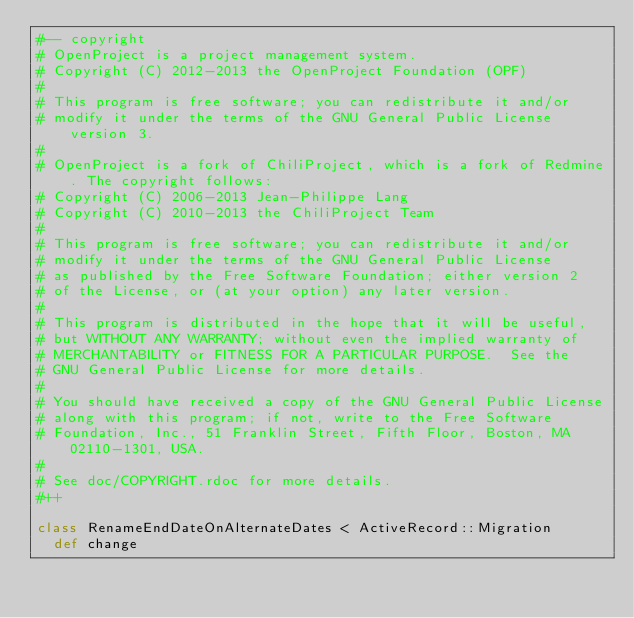<code> <loc_0><loc_0><loc_500><loc_500><_Ruby_>#-- copyright
# OpenProject is a project management system.
# Copyright (C) 2012-2013 the OpenProject Foundation (OPF)
#
# This program is free software; you can redistribute it and/or
# modify it under the terms of the GNU General Public License version 3.
#
# OpenProject is a fork of ChiliProject, which is a fork of Redmine. The copyright follows:
# Copyright (C) 2006-2013 Jean-Philippe Lang
# Copyright (C) 2010-2013 the ChiliProject Team
#
# This program is free software; you can redistribute it and/or
# modify it under the terms of the GNU General Public License
# as published by the Free Software Foundation; either version 2
# of the License, or (at your option) any later version.
#
# This program is distributed in the hope that it will be useful,
# but WITHOUT ANY WARRANTY; without even the implied warranty of
# MERCHANTABILITY or FITNESS FOR A PARTICULAR PURPOSE.  See the
# GNU General Public License for more details.
#
# You should have received a copy of the GNU General Public License
# along with this program; if not, write to the Free Software
# Foundation, Inc., 51 Franklin Street, Fifth Floor, Boston, MA  02110-1301, USA.
#
# See doc/COPYRIGHT.rdoc for more details.
#++

class RenameEndDateOnAlternateDates < ActiveRecord::Migration
  def change</code> 